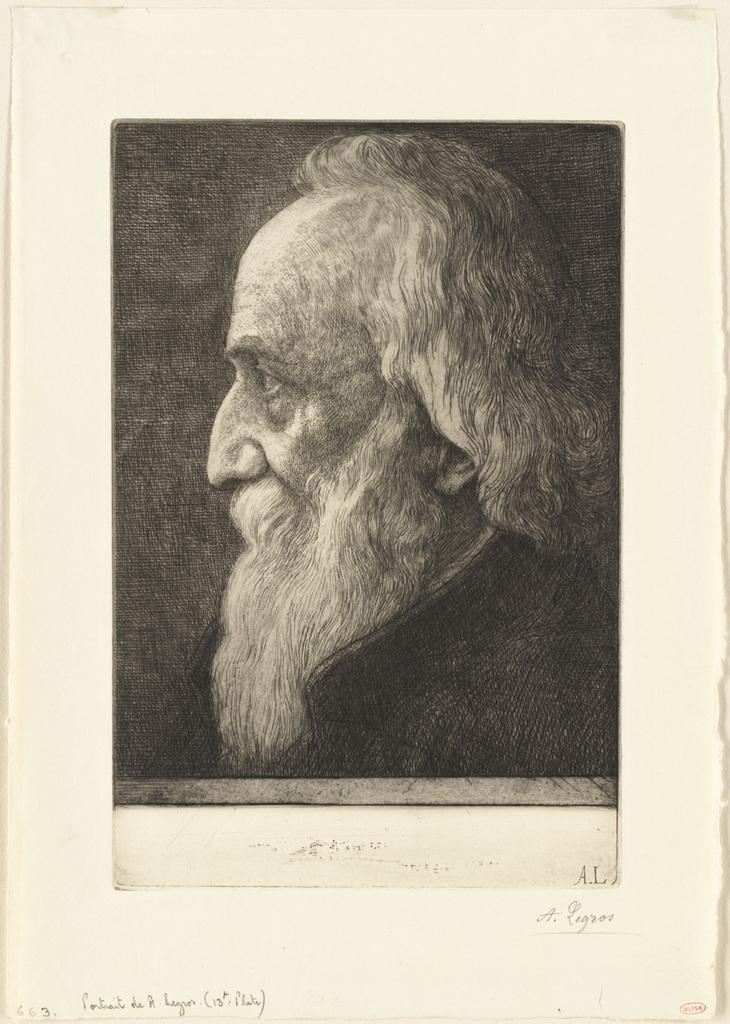What is the main subject of the image? The main subject of the image is the cover page of a book. What can be seen on the cover page? The cover page has a picture of a person. How many dimes are scattered across the cover page of the book? There are no dimes present on the cover page of the book; it features a picture of a person. What type of farm can be seen in the background of the cover page? There is no farm visible on the cover page of the book; it only features a picture of a person. 